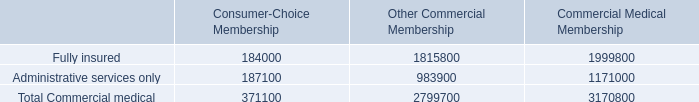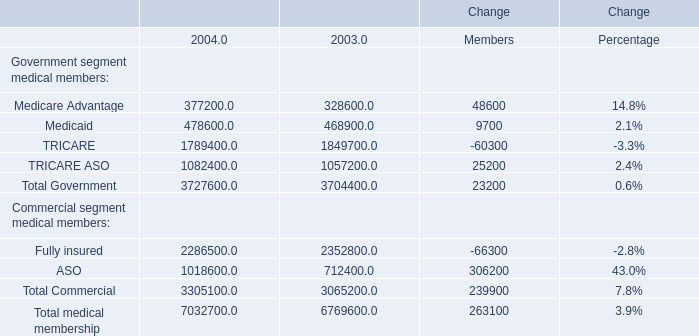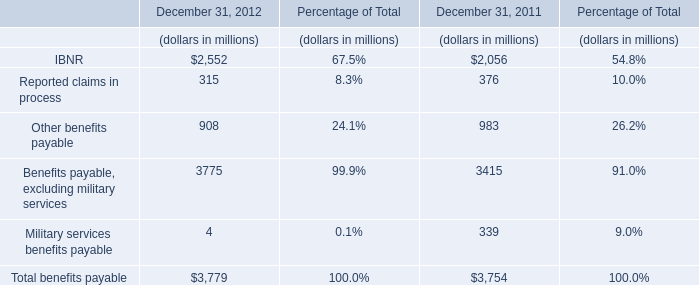as of december 31 2005 what was the approximate number of total commercial medical membership 
Computations: (371100 / 11.7%)
Answer: 3171794.87179. 